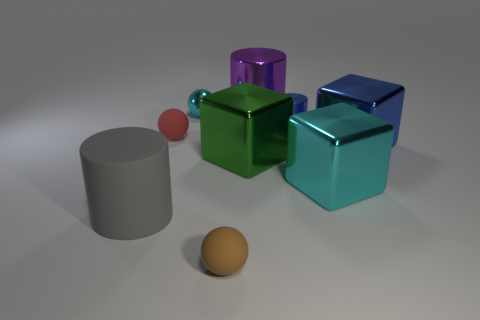Subtract all red blocks. Subtract all gray cylinders. How many blocks are left? 3 Subtract all cubes. How many objects are left? 6 Subtract all big blocks. Subtract all big purple metal objects. How many objects are left? 5 Add 2 cyan cubes. How many cyan cubes are left? 3 Add 3 small blue rubber cylinders. How many small blue rubber cylinders exist? 3 Subtract 0 yellow cylinders. How many objects are left? 9 